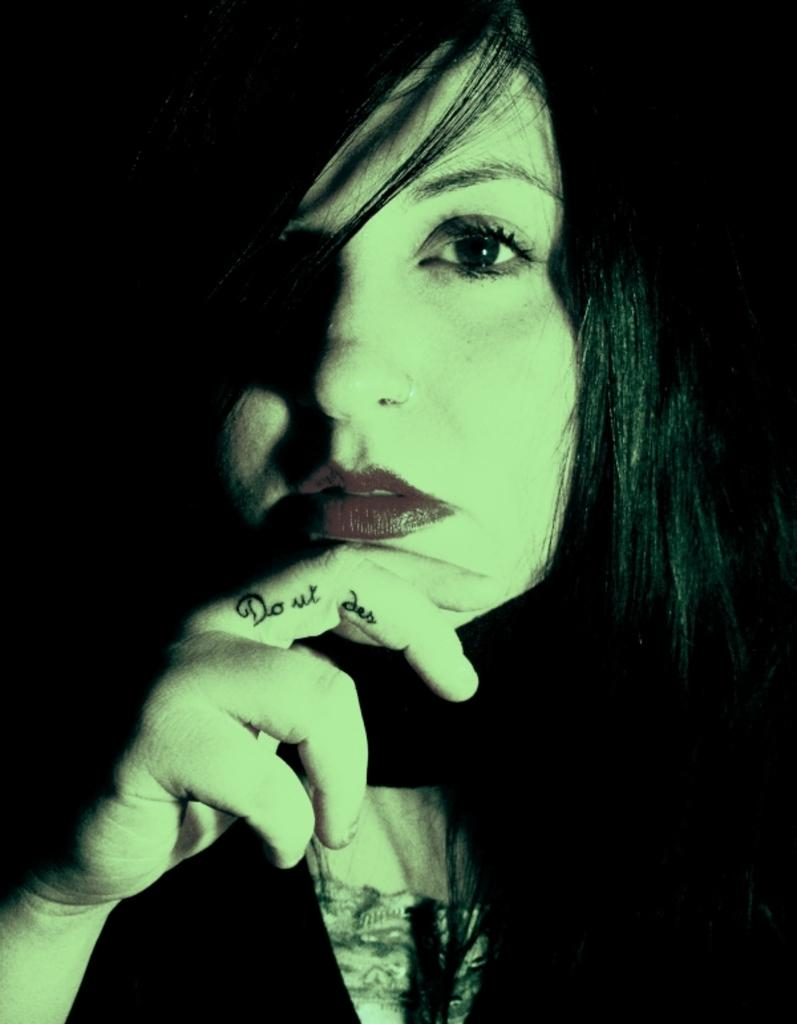Who is the main subject in the image? There is a woman in the image. What distinguishing feature can be seen on the woman's finger? The woman has a tattoo on her finger. What is the color of the background in the image? The background of the image is dark in color. What type of music is the woman's friend playing in the background of the image? There is no friend or music present in the image, so it cannot be determined what type of music might be playing. 